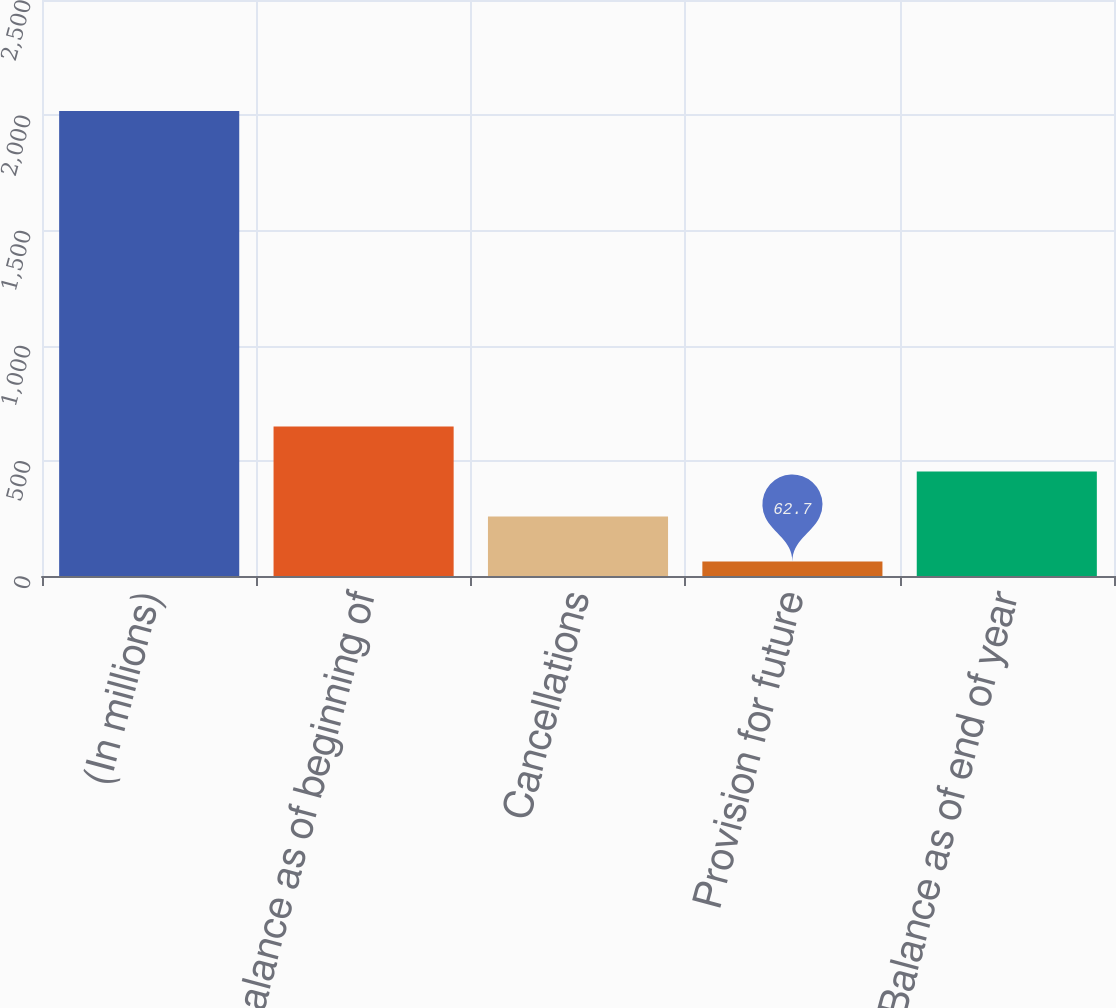Convert chart. <chart><loc_0><loc_0><loc_500><loc_500><bar_chart><fcel>(In millions)<fcel>Balance as of beginning of<fcel>Cancellations<fcel>Provision for future<fcel>Balance as of end of year<nl><fcel>2018<fcel>649.29<fcel>258.23<fcel>62.7<fcel>453.76<nl></chart> 